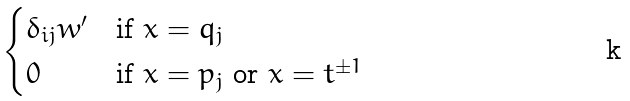Convert formula to latex. <formula><loc_0><loc_0><loc_500><loc_500>\begin{cases} \delta _ { i j } w ^ { \prime } & \text {if $x = q_{j}$} \\ 0 & \text {if $x = p_{j}$ or $x = t^{\pm 1}$} \end{cases}</formula> 